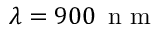<formula> <loc_0><loc_0><loc_500><loc_500>\lambda = 9 0 0 \, n m</formula> 